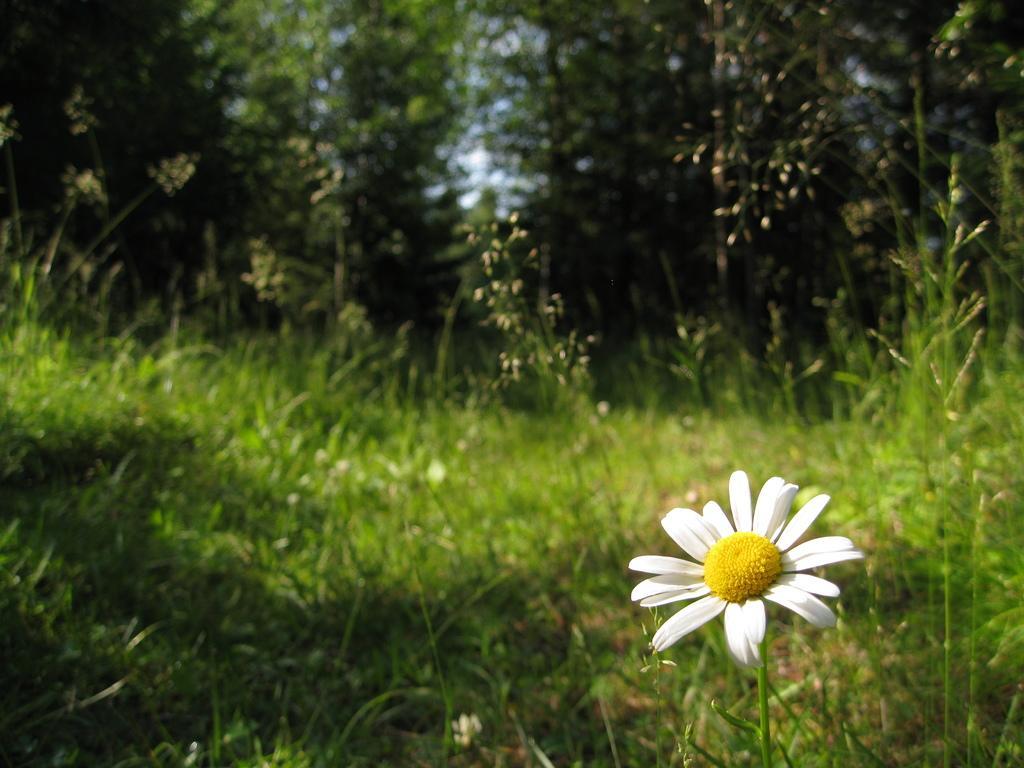Describe this image in one or two sentences. In this image we can see land full of grass. Behind trees are present. Bottom right of the image one white color flower is present. 